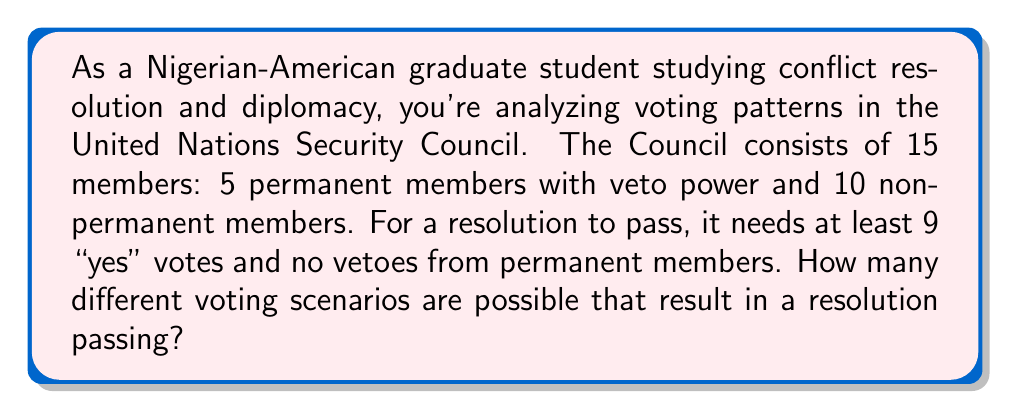Give your solution to this math problem. Let's approach this step-by-step:

1) First, we need to consider the permanent members. For a resolution to pass, none of them can veto. This means all 5 permanent members must either vote "yes" or abstain.

2) Let's define our variables:
   $p$ = number of permanent members voting "yes"
   $n$ = number of non-permanent members voting "yes"

3) We know that $0 \leq p \leq 5$ and $0 \leq n \leq 10$

4) For a resolution to pass, we need:
   $p + n \geq 9$

5) Now, let's consider each possible value of $p$:

   When $p = 5$: We need $n \geq 4$. There are $\binom{10}{4} + \binom{10}{5} + ... + \binom{10}{10} = 386$ ways.
   
   When $p = 4$: We need $n \geq 5$. There are $\binom{10}{5} + \binom{10}{6} + ... + \binom{10}{10} = 252$ ways.
   
   When $p = 3$: We need $n \geq 6$. There are $\binom{10}{6} + \binom{10}{7} + ... + \binom{10}{10} = 120$ ways.
   
   When $p = 2$: We need $n \geq 7$. There are $\binom{10}{7} + \binom{10}{8} + \binom{10}{9} + \binom{10}{10} = 45$ ways.
   
   When $p = 1$: We need $n \geq 8$. There are $\binom{10}{8} + \binom{10}{9} + \binom{10}{10} = 12$ ways.
   
   When $p = 0$: We need $n \geq 9$. There are $\binom{10}{9} + \binom{10}{10} = 11$ ways.

6) The total number of passing scenarios is the sum of all these possibilities:

   $386 + 252 + 120 + 45 + 12 + 11 = 826$

Therefore, there are 826 different voting scenarios that result in a resolution passing.
Answer: 826 voting scenarios 